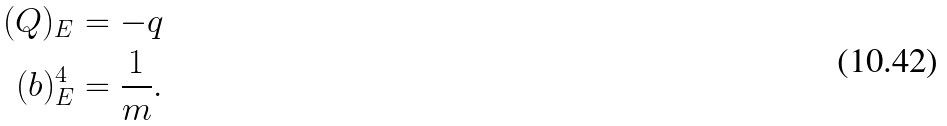Convert formula to latex. <formula><loc_0><loc_0><loc_500><loc_500>( Q ) _ { E } & = - q \\ ( b ) _ { E } ^ { 4 } & = \frac { 1 } { m } .</formula> 